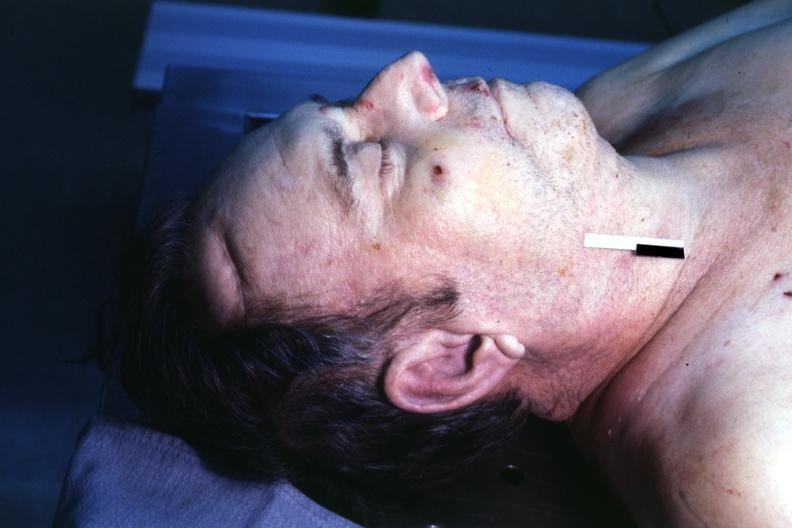what is easily seen?
Answer the question using a single word or phrase. Body on autopsy table lesion that supposedly predicts premature coronary disease 